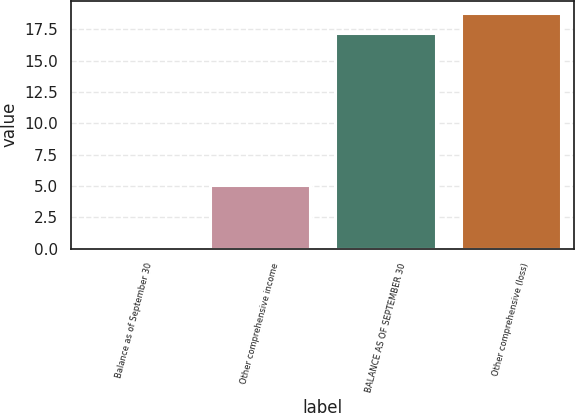<chart> <loc_0><loc_0><loc_500><loc_500><bar_chart><fcel>Balance as of September 30<fcel>Other comprehensive income<fcel>BALANCE AS OF SEPTEMBER 30<fcel>Other comprehensive (loss)<nl><fcel>0.2<fcel>5.12<fcel>17.18<fcel>18.82<nl></chart> 